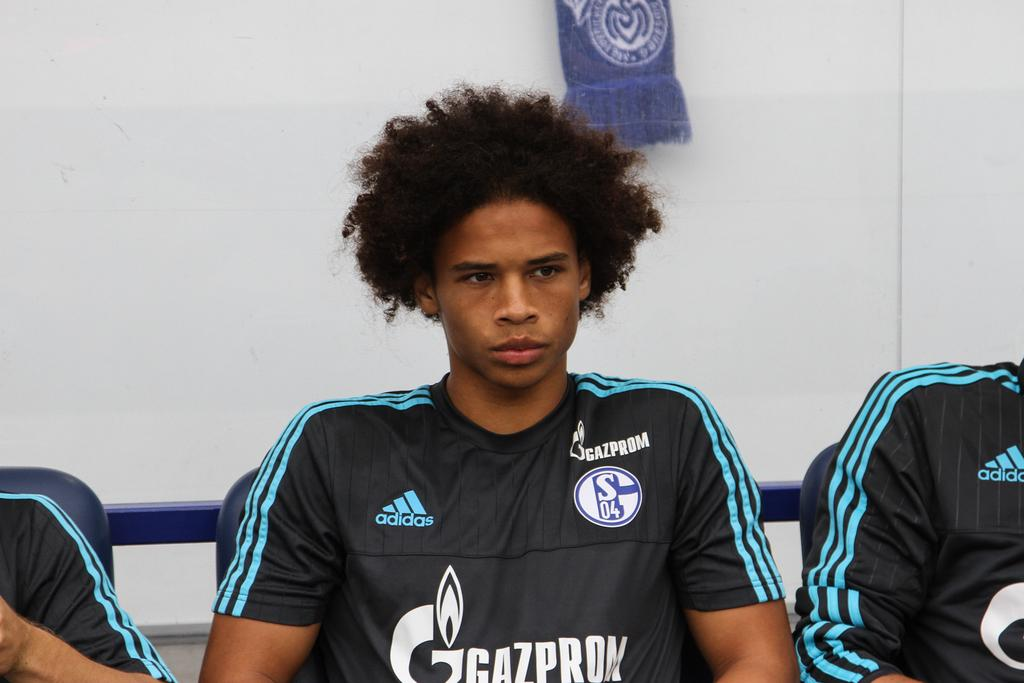Provide a one-sentence caption for the provided image. A Gazprom player with an afro sits looking upset while wearing the charcoal and teal jersey. 